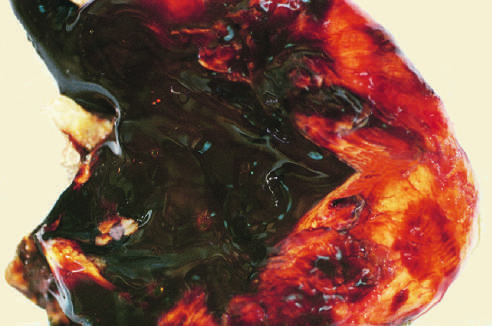what shows a large endometriotic cyst with degenerated blood (chocolate cyst)?
Answer the question using a single word or phrase. Sectioning of ovary 